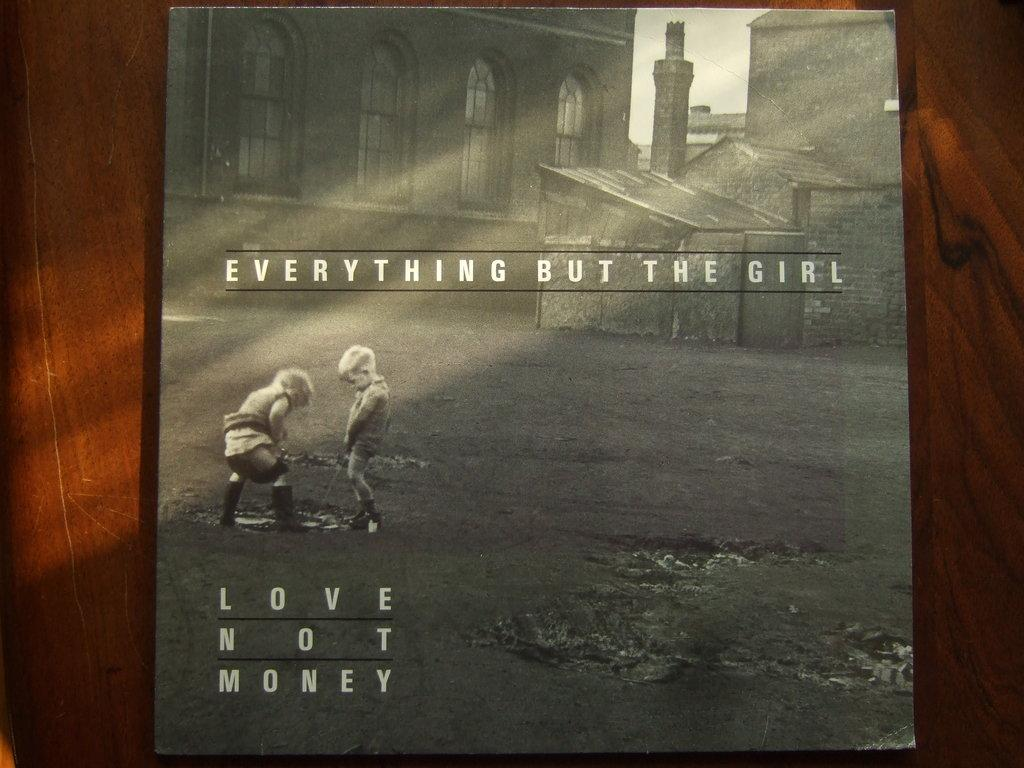What is the main object in the middle of the image? There is a board in the middle of the image. What can be seen on the board? The board has images on it and text. Can you describe the background of the image? There is a wooden piece in the background of the image. Is there any plastic furniture visible in the image? There is no plastic furniture present in the image. Can you see your aunt in the image? There is no reference to an aunt or any person in the image. 